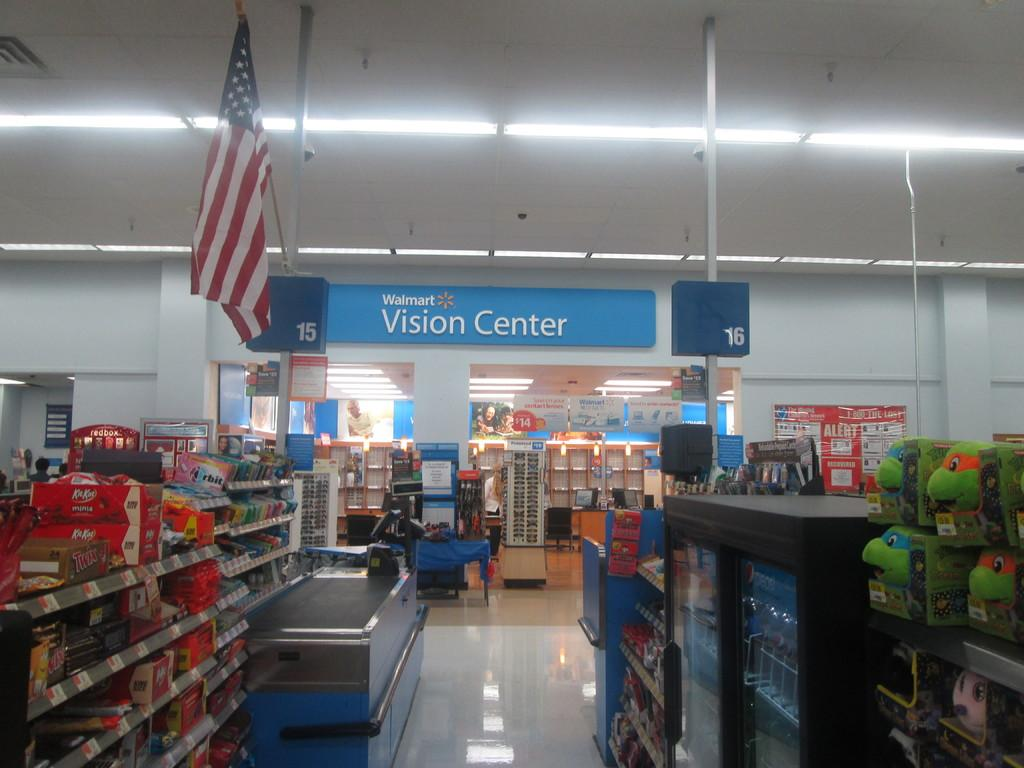<image>
Give a short and clear explanation of the subsequent image. The aisles leading up to the Walmart Vision Center 